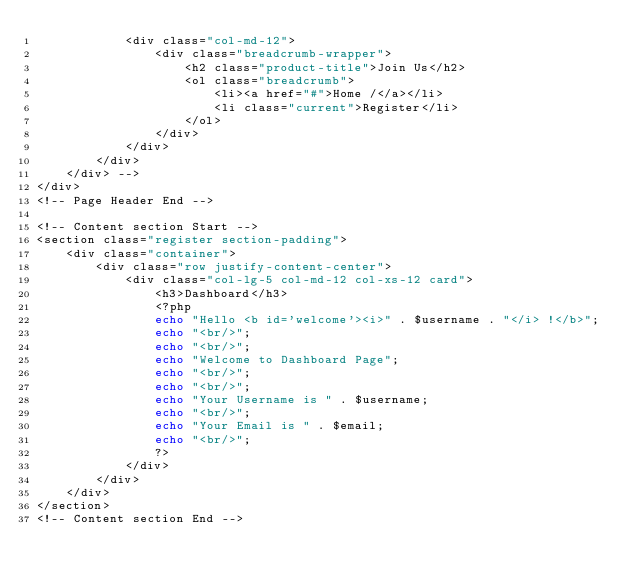<code> <loc_0><loc_0><loc_500><loc_500><_PHP_>            <div class="col-md-12">
                <div class="breadcrumb-wrapper">
                    <h2 class="product-title">Join Us</h2>
                    <ol class="breadcrumb">
                        <li><a href="#">Home /</a></li>
                        <li class="current">Register</li>
                    </ol>
                </div>
            </div>
        </div>
    </div> -->
</div>
<!-- Page Header End -->

<!-- Content section Start -->
<section class="register section-padding">
    <div class="container">
        <div class="row justify-content-center">
            <div class="col-lg-5 col-md-12 col-xs-12 card">
                <h3>Dashboard</h3>
                <?php
                echo "Hello <b id='welcome'><i>" . $username . "</i> !</b>";
                echo "<br/>";
                echo "<br/>";
                echo "Welcome to Dashboard Page";
                echo "<br/>";
                echo "<br/>";
                echo "Your Username is " . $username;
                echo "<br/>";
                echo "Your Email is " . $email;
                echo "<br/>";
                ?>
            </div>
        </div>
    </div>
</section>
<!-- Content section End --></code> 